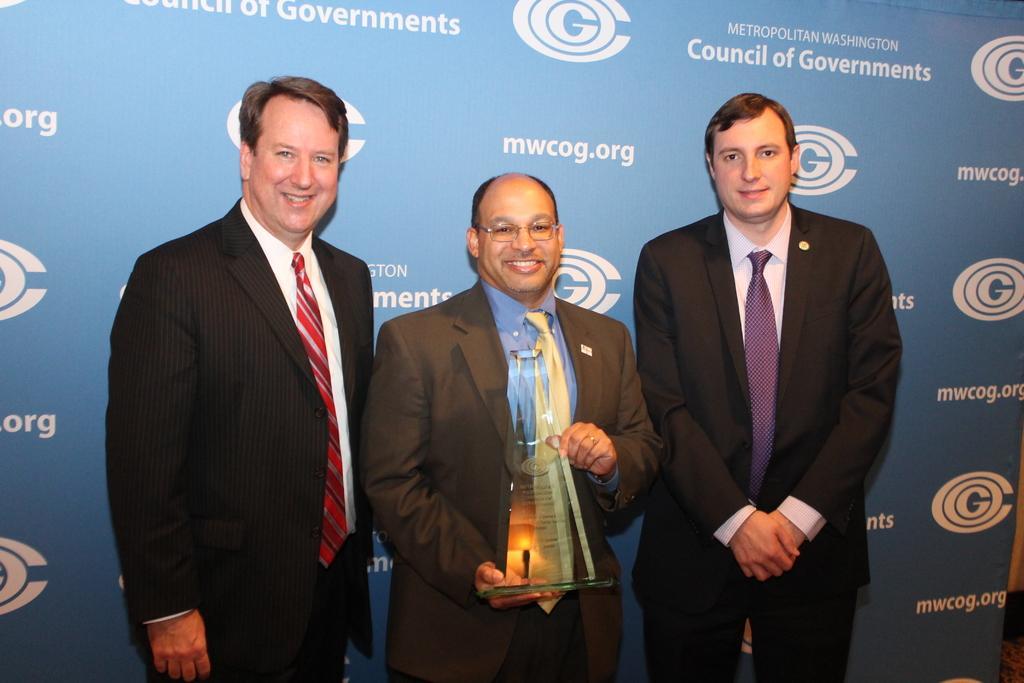Describe this image in one or two sentences. In the center of the image we can see three men are standing and smiling and wearing the suits, ties and a man is holding a trophy. In the background of the image we can see the board. On the board we can see the text and logos. 